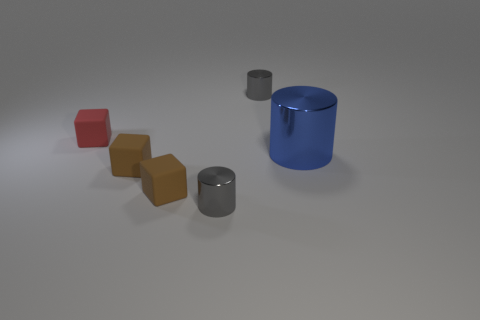The big object on the right side of the tiny gray cylinder in front of the object behind the small red matte thing is what color? blue 